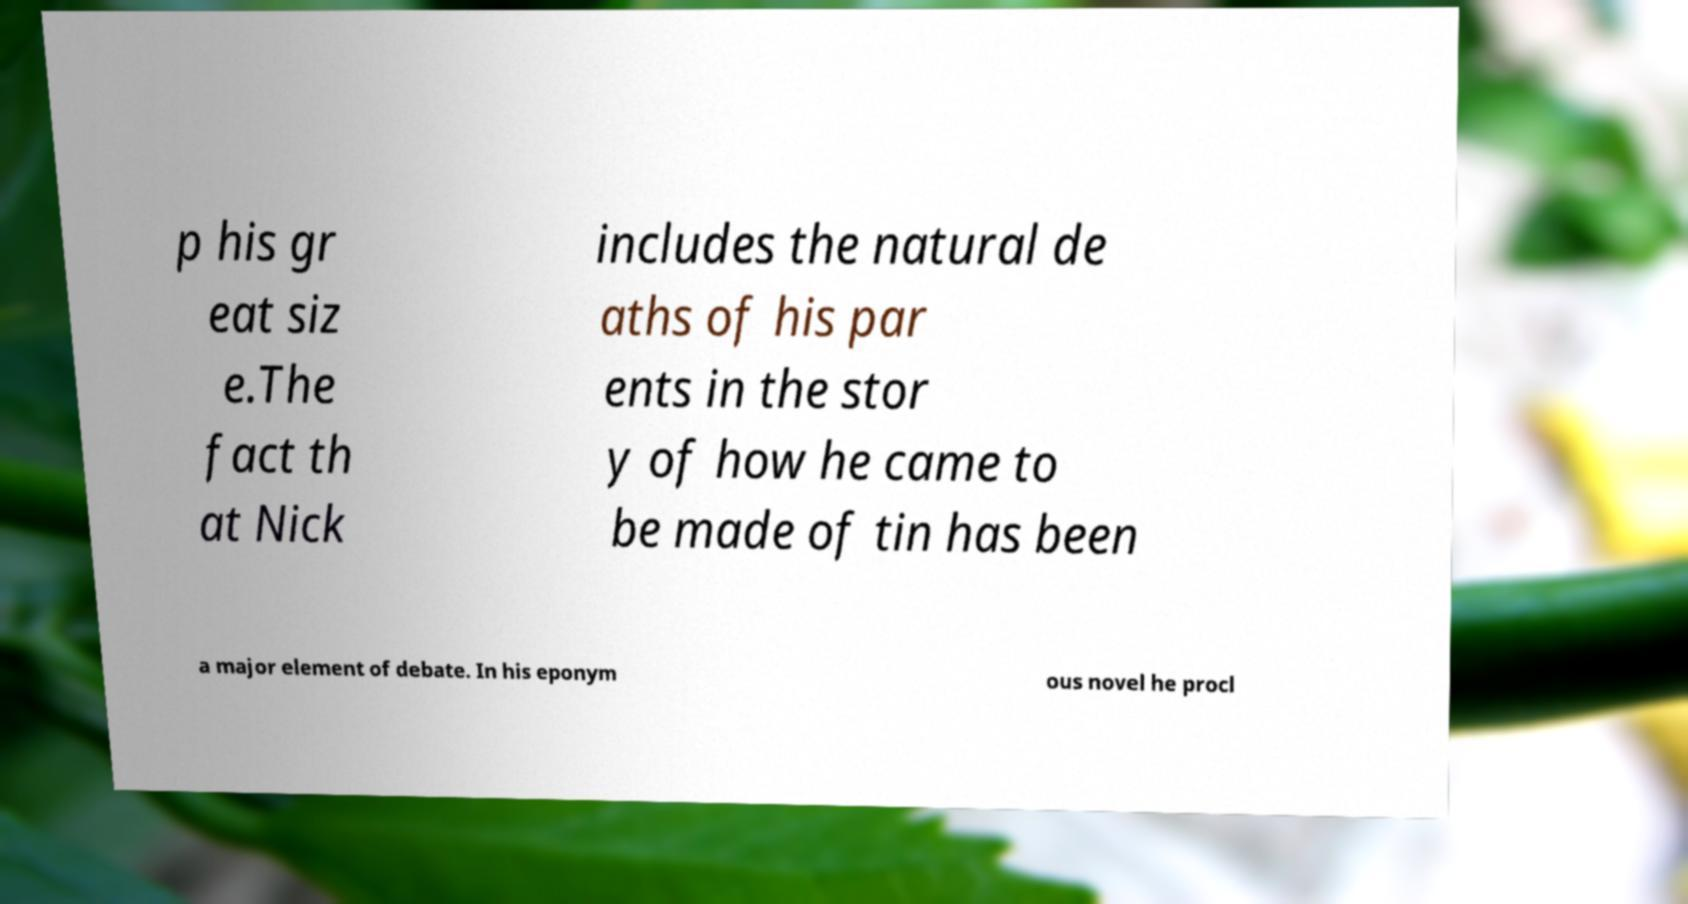I need the written content from this picture converted into text. Can you do that? p his gr eat siz e.The fact th at Nick includes the natural de aths of his par ents in the stor y of how he came to be made of tin has been a major element of debate. In his eponym ous novel he procl 